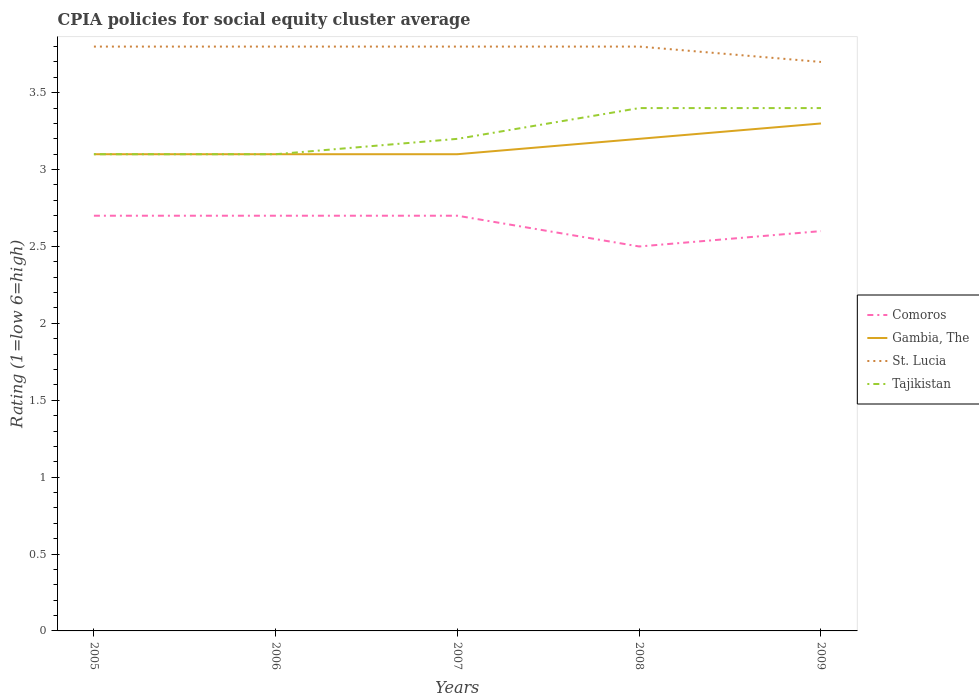Does the line corresponding to Gambia, The intersect with the line corresponding to Comoros?
Ensure brevity in your answer.  No. Across all years, what is the maximum CPIA rating in St. Lucia?
Keep it short and to the point. 3.7. What is the total CPIA rating in Comoros in the graph?
Provide a short and direct response. 0.2. What is the difference between the highest and the second highest CPIA rating in Tajikistan?
Ensure brevity in your answer.  0.3. How many lines are there?
Your answer should be compact. 4. How many years are there in the graph?
Make the answer very short. 5. What is the difference between two consecutive major ticks on the Y-axis?
Provide a short and direct response. 0.5. Are the values on the major ticks of Y-axis written in scientific E-notation?
Provide a short and direct response. No. How many legend labels are there?
Give a very brief answer. 4. What is the title of the graph?
Your answer should be compact. CPIA policies for social equity cluster average. What is the label or title of the X-axis?
Ensure brevity in your answer.  Years. What is the label or title of the Y-axis?
Your response must be concise. Rating (1=low 6=high). What is the Rating (1=low 6=high) of St. Lucia in 2005?
Provide a short and direct response. 3.8. What is the Rating (1=low 6=high) of Tajikistan in 2005?
Offer a very short reply. 3.1. What is the Rating (1=low 6=high) of Comoros in 2006?
Provide a succinct answer. 2.7. What is the Rating (1=low 6=high) of Comoros in 2007?
Offer a terse response. 2.7. What is the Rating (1=low 6=high) of Gambia, The in 2007?
Offer a terse response. 3.1. What is the Rating (1=low 6=high) of St. Lucia in 2007?
Your response must be concise. 3.8. What is the Rating (1=low 6=high) in Tajikistan in 2007?
Ensure brevity in your answer.  3.2. What is the Rating (1=low 6=high) in Tajikistan in 2008?
Offer a terse response. 3.4. What is the Rating (1=low 6=high) of St. Lucia in 2009?
Offer a very short reply. 3.7. Across all years, what is the maximum Rating (1=low 6=high) in Comoros?
Keep it short and to the point. 2.7. Across all years, what is the maximum Rating (1=low 6=high) in Tajikistan?
Provide a short and direct response. 3.4. Across all years, what is the minimum Rating (1=low 6=high) in Comoros?
Ensure brevity in your answer.  2.5. What is the difference between the Rating (1=low 6=high) in Gambia, The in 2005 and that in 2006?
Your response must be concise. 0. What is the difference between the Rating (1=low 6=high) in Tajikistan in 2005 and that in 2006?
Give a very brief answer. 0. What is the difference between the Rating (1=low 6=high) in Gambia, The in 2005 and that in 2007?
Keep it short and to the point. 0. What is the difference between the Rating (1=low 6=high) in Comoros in 2005 and that in 2008?
Provide a succinct answer. 0.2. What is the difference between the Rating (1=low 6=high) of Tajikistan in 2005 and that in 2008?
Offer a terse response. -0.3. What is the difference between the Rating (1=low 6=high) in St. Lucia in 2005 and that in 2009?
Your answer should be compact. 0.1. What is the difference between the Rating (1=low 6=high) of Comoros in 2006 and that in 2007?
Offer a terse response. 0. What is the difference between the Rating (1=low 6=high) in Gambia, The in 2006 and that in 2007?
Provide a short and direct response. 0. What is the difference between the Rating (1=low 6=high) in Comoros in 2006 and that in 2008?
Provide a short and direct response. 0.2. What is the difference between the Rating (1=low 6=high) of Gambia, The in 2006 and that in 2008?
Make the answer very short. -0.1. What is the difference between the Rating (1=low 6=high) of St. Lucia in 2006 and that in 2008?
Ensure brevity in your answer.  0. What is the difference between the Rating (1=low 6=high) of Comoros in 2006 and that in 2009?
Provide a succinct answer. 0.1. What is the difference between the Rating (1=low 6=high) of Gambia, The in 2006 and that in 2009?
Keep it short and to the point. -0.2. What is the difference between the Rating (1=low 6=high) of St. Lucia in 2006 and that in 2009?
Provide a succinct answer. 0.1. What is the difference between the Rating (1=low 6=high) of Comoros in 2007 and that in 2008?
Make the answer very short. 0.2. What is the difference between the Rating (1=low 6=high) in Gambia, The in 2007 and that in 2008?
Offer a very short reply. -0.1. What is the difference between the Rating (1=low 6=high) of Tajikistan in 2007 and that in 2008?
Provide a succinct answer. -0.2. What is the difference between the Rating (1=low 6=high) in Gambia, The in 2007 and that in 2009?
Give a very brief answer. -0.2. What is the difference between the Rating (1=low 6=high) of Tajikistan in 2007 and that in 2009?
Your answer should be compact. -0.2. What is the difference between the Rating (1=low 6=high) of Gambia, The in 2008 and that in 2009?
Keep it short and to the point. -0.1. What is the difference between the Rating (1=low 6=high) in Tajikistan in 2008 and that in 2009?
Your answer should be compact. 0. What is the difference between the Rating (1=low 6=high) in Comoros in 2005 and the Rating (1=low 6=high) in St. Lucia in 2006?
Make the answer very short. -1.1. What is the difference between the Rating (1=low 6=high) in Comoros in 2005 and the Rating (1=low 6=high) in Tajikistan in 2006?
Give a very brief answer. -0.4. What is the difference between the Rating (1=low 6=high) of Comoros in 2005 and the Rating (1=low 6=high) of Gambia, The in 2007?
Your response must be concise. -0.4. What is the difference between the Rating (1=low 6=high) in Comoros in 2005 and the Rating (1=low 6=high) in St. Lucia in 2007?
Give a very brief answer. -1.1. What is the difference between the Rating (1=low 6=high) in Gambia, The in 2005 and the Rating (1=low 6=high) in St. Lucia in 2007?
Your response must be concise. -0.7. What is the difference between the Rating (1=low 6=high) of Comoros in 2005 and the Rating (1=low 6=high) of Gambia, The in 2008?
Provide a succinct answer. -0.5. What is the difference between the Rating (1=low 6=high) of Comoros in 2005 and the Rating (1=low 6=high) of Tajikistan in 2008?
Ensure brevity in your answer.  -0.7. What is the difference between the Rating (1=low 6=high) in Gambia, The in 2005 and the Rating (1=low 6=high) in St. Lucia in 2008?
Your response must be concise. -0.7. What is the difference between the Rating (1=low 6=high) of Comoros in 2005 and the Rating (1=low 6=high) of Gambia, The in 2009?
Provide a short and direct response. -0.6. What is the difference between the Rating (1=low 6=high) in Comoros in 2005 and the Rating (1=low 6=high) in St. Lucia in 2009?
Make the answer very short. -1. What is the difference between the Rating (1=low 6=high) of Comoros in 2006 and the Rating (1=low 6=high) of Gambia, The in 2007?
Offer a terse response. -0.4. What is the difference between the Rating (1=low 6=high) of Comoros in 2006 and the Rating (1=low 6=high) of St. Lucia in 2007?
Provide a short and direct response. -1.1. What is the difference between the Rating (1=low 6=high) of Comoros in 2006 and the Rating (1=low 6=high) of Tajikistan in 2007?
Your answer should be very brief. -0.5. What is the difference between the Rating (1=low 6=high) in Gambia, The in 2006 and the Rating (1=low 6=high) in Tajikistan in 2007?
Your response must be concise. -0.1. What is the difference between the Rating (1=low 6=high) of St. Lucia in 2006 and the Rating (1=low 6=high) of Tajikistan in 2007?
Give a very brief answer. 0.6. What is the difference between the Rating (1=low 6=high) of Comoros in 2006 and the Rating (1=low 6=high) of Gambia, The in 2008?
Make the answer very short. -0.5. What is the difference between the Rating (1=low 6=high) of Gambia, The in 2006 and the Rating (1=low 6=high) of Tajikistan in 2008?
Make the answer very short. -0.3. What is the difference between the Rating (1=low 6=high) in St. Lucia in 2006 and the Rating (1=low 6=high) in Tajikistan in 2008?
Keep it short and to the point. 0.4. What is the difference between the Rating (1=low 6=high) in Comoros in 2006 and the Rating (1=low 6=high) in St. Lucia in 2009?
Give a very brief answer. -1. What is the difference between the Rating (1=low 6=high) in Comoros in 2007 and the Rating (1=low 6=high) in St. Lucia in 2008?
Ensure brevity in your answer.  -1.1. What is the difference between the Rating (1=low 6=high) of Gambia, The in 2007 and the Rating (1=low 6=high) of Tajikistan in 2008?
Provide a short and direct response. -0.3. What is the difference between the Rating (1=low 6=high) of Comoros in 2007 and the Rating (1=low 6=high) of Tajikistan in 2009?
Keep it short and to the point. -0.7. What is the difference between the Rating (1=low 6=high) in Comoros in 2008 and the Rating (1=low 6=high) in Gambia, The in 2009?
Make the answer very short. -0.8. What is the difference between the Rating (1=low 6=high) of Comoros in 2008 and the Rating (1=low 6=high) of St. Lucia in 2009?
Provide a succinct answer. -1.2. What is the difference between the Rating (1=low 6=high) in Comoros in 2008 and the Rating (1=low 6=high) in Tajikistan in 2009?
Keep it short and to the point. -0.9. What is the average Rating (1=low 6=high) in Comoros per year?
Your response must be concise. 2.64. What is the average Rating (1=low 6=high) of Gambia, The per year?
Provide a short and direct response. 3.16. What is the average Rating (1=low 6=high) of St. Lucia per year?
Offer a terse response. 3.78. What is the average Rating (1=low 6=high) in Tajikistan per year?
Your answer should be compact. 3.24. In the year 2005, what is the difference between the Rating (1=low 6=high) of Comoros and Rating (1=low 6=high) of Gambia, The?
Your response must be concise. -0.4. In the year 2005, what is the difference between the Rating (1=low 6=high) of Comoros and Rating (1=low 6=high) of Tajikistan?
Provide a short and direct response. -0.4. In the year 2005, what is the difference between the Rating (1=low 6=high) of Gambia, The and Rating (1=low 6=high) of Tajikistan?
Offer a very short reply. 0. In the year 2006, what is the difference between the Rating (1=low 6=high) in Comoros and Rating (1=low 6=high) in Tajikistan?
Make the answer very short. -0.4. In the year 2006, what is the difference between the Rating (1=low 6=high) in Gambia, The and Rating (1=low 6=high) in St. Lucia?
Your response must be concise. -0.7. In the year 2006, what is the difference between the Rating (1=low 6=high) in Gambia, The and Rating (1=low 6=high) in Tajikistan?
Your answer should be compact. 0. In the year 2006, what is the difference between the Rating (1=low 6=high) in St. Lucia and Rating (1=low 6=high) in Tajikistan?
Your answer should be compact. 0.7. In the year 2007, what is the difference between the Rating (1=low 6=high) of Comoros and Rating (1=low 6=high) of St. Lucia?
Make the answer very short. -1.1. In the year 2007, what is the difference between the Rating (1=low 6=high) in Gambia, The and Rating (1=low 6=high) in St. Lucia?
Your response must be concise. -0.7. In the year 2008, what is the difference between the Rating (1=low 6=high) of Comoros and Rating (1=low 6=high) of St. Lucia?
Give a very brief answer. -1.3. In the year 2008, what is the difference between the Rating (1=low 6=high) in Comoros and Rating (1=low 6=high) in Tajikistan?
Your answer should be very brief. -0.9. In the year 2008, what is the difference between the Rating (1=low 6=high) in Gambia, The and Rating (1=low 6=high) in St. Lucia?
Give a very brief answer. -0.6. In the year 2008, what is the difference between the Rating (1=low 6=high) in Gambia, The and Rating (1=low 6=high) in Tajikistan?
Provide a short and direct response. -0.2. In the year 2009, what is the difference between the Rating (1=low 6=high) of Gambia, The and Rating (1=low 6=high) of St. Lucia?
Keep it short and to the point. -0.4. In the year 2009, what is the difference between the Rating (1=low 6=high) in Gambia, The and Rating (1=low 6=high) in Tajikistan?
Make the answer very short. -0.1. What is the ratio of the Rating (1=low 6=high) in Comoros in 2005 to that in 2006?
Make the answer very short. 1. What is the ratio of the Rating (1=low 6=high) of St. Lucia in 2005 to that in 2007?
Offer a terse response. 1. What is the ratio of the Rating (1=low 6=high) in Tajikistan in 2005 to that in 2007?
Your answer should be very brief. 0.97. What is the ratio of the Rating (1=low 6=high) of Gambia, The in 2005 to that in 2008?
Give a very brief answer. 0.97. What is the ratio of the Rating (1=low 6=high) in Tajikistan in 2005 to that in 2008?
Offer a terse response. 0.91. What is the ratio of the Rating (1=low 6=high) in Comoros in 2005 to that in 2009?
Keep it short and to the point. 1.04. What is the ratio of the Rating (1=low 6=high) in Gambia, The in 2005 to that in 2009?
Give a very brief answer. 0.94. What is the ratio of the Rating (1=low 6=high) in Tajikistan in 2005 to that in 2009?
Your response must be concise. 0.91. What is the ratio of the Rating (1=low 6=high) in Tajikistan in 2006 to that in 2007?
Provide a short and direct response. 0.97. What is the ratio of the Rating (1=low 6=high) of Comoros in 2006 to that in 2008?
Provide a short and direct response. 1.08. What is the ratio of the Rating (1=low 6=high) of Gambia, The in 2006 to that in 2008?
Make the answer very short. 0.97. What is the ratio of the Rating (1=low 6=high) of St. Lucia in 2006 to that in 2008?
Offer a very short reply. 1. What is the ratio of the Rating (1=low 6=high) of Tajikistan in 2006 to that in 2008?
Your answer should be very brief. 0.91. What is the ratio of the Rating (1=low 6=high) of Gambia, The in 2006 to that in 2009?
Give a very brief answer. 0.94. What is the ratio of the Rating (1=low 6=high) of St. Lucia in 2006 to that in 2009?
Give a very brief answer. 1.03. What is the ratio of the Rating (1=low 6=high) of Tajikistan in 2006 to that in 2009?
Provide a short and direct response. 0.91. What is the ratio of the Rating (1=low 6=high) of Gambia, The in 2007 to that in 2008?
Keep it short and to the point. 0.97. What is the ratio of the Rating (1=low 6=high) in Tajikistan in 2007 to that in 2008?
Offer a terse response. 0.94. What is the ratio of the Rating (1=low 6=high) in Comoros in 2007 to that in 2009?
Your answer should be compact. 1.04. What is the ratio of the Rating (1=low 6=high) of Gambia, The in 2007 to that in 2009?
Your response must be concise. 0.94. What is the ratio of the Rating (1=low 6=high) in Tajikistan in 2007 to that in 2009?
Offer a very short reply. 0.94. What is the ratio of the Rating (1=low 6=high) of Comoros in 2008 to that in 2009?
Ensure brevity in your answer.  0.96. What is the ratio of the Rating (1=low 6=high) in Gambia, The in 2008 to that in 2009?
Your answer should be very brief. 0.97. What is the ratio of the Rating (1=low 6=high) of St. Lucia in 2008 to that in 2009?
Your response must be concise. 1.03. What is the ratio of the Rating (1=low 6=high) of Tajikistan in 2008 to that in 2009?
Offer a terse response. 1. What is the difference between the highest and the lowest Rating (1=low 6=high) of Comoros?
Provide a short and direct response. 0.2. What is the difference between the highest and the lowest Rating (1=low 6=high) of Gambia, The?
Keep it short and to the point. 0.2. 